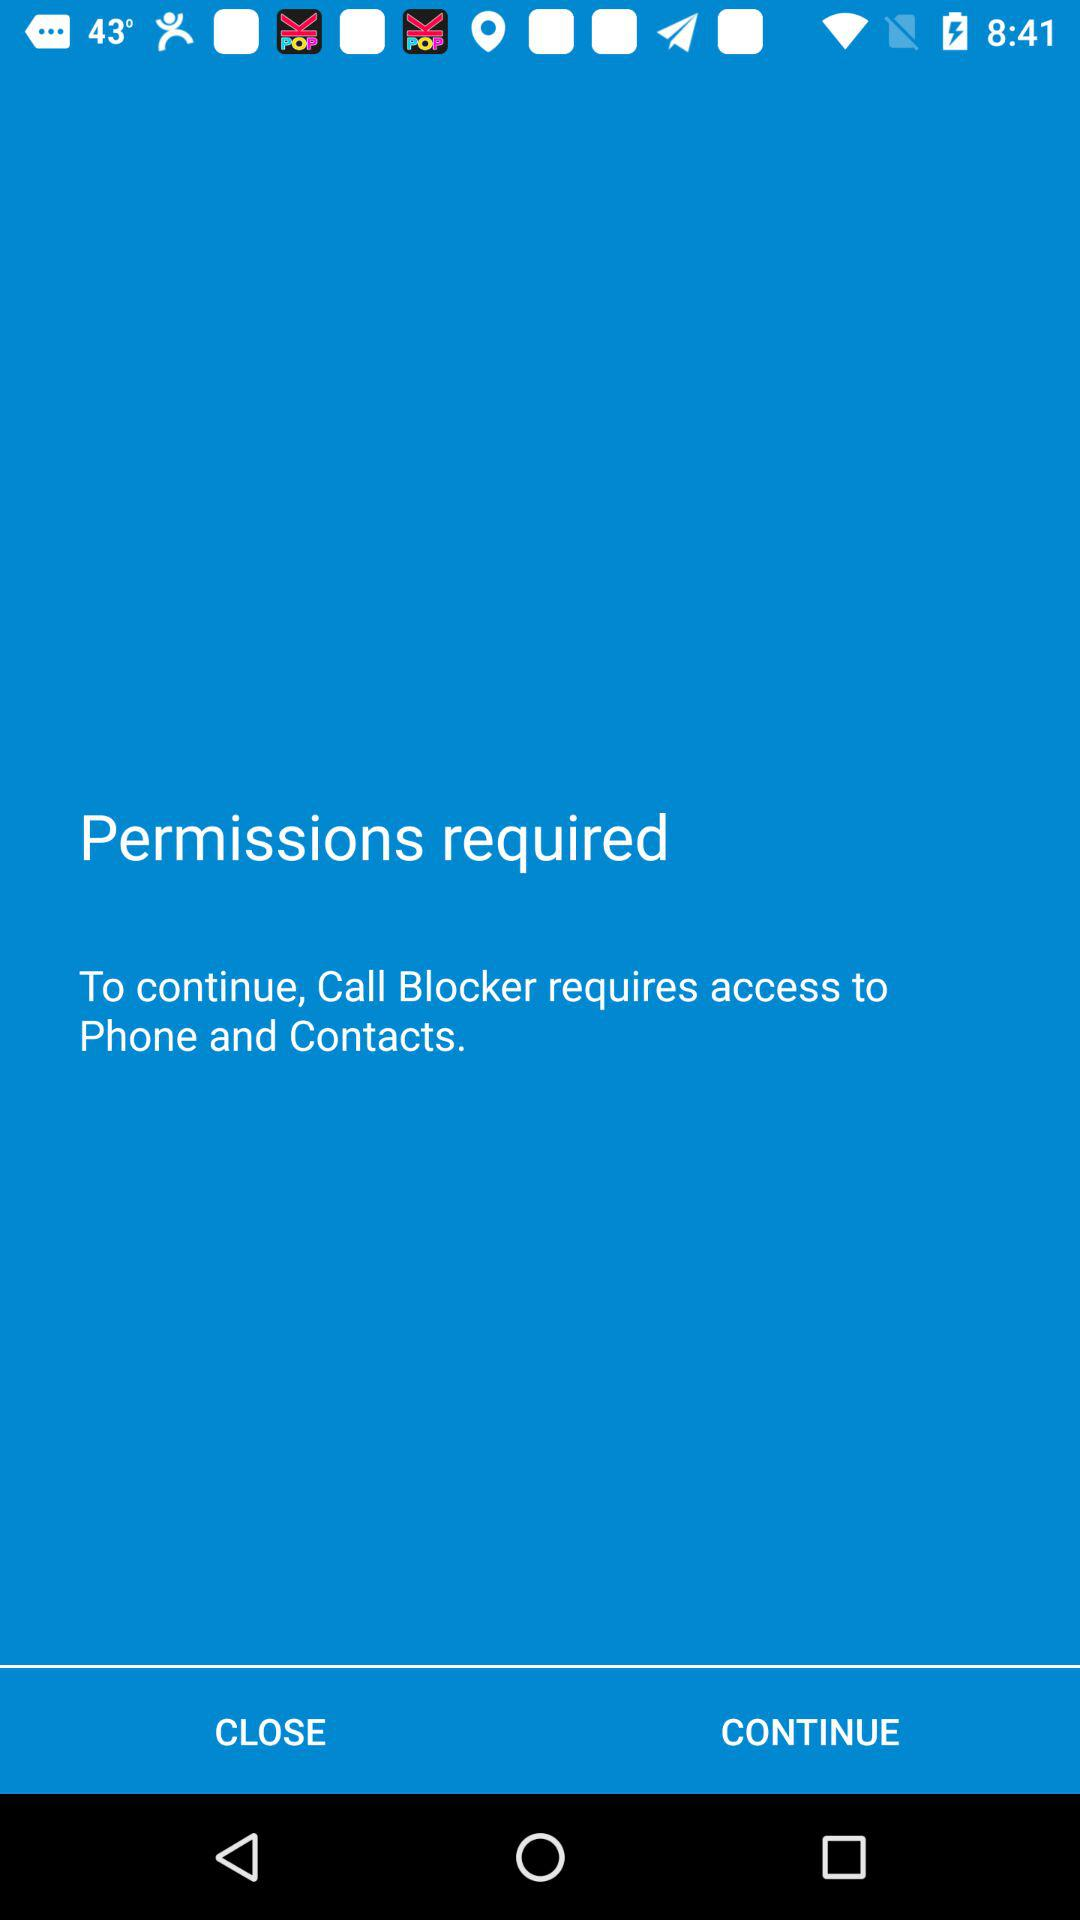What permission does a "Call Blocker" require? Call Blocker requires access to Phone and Contacts. 